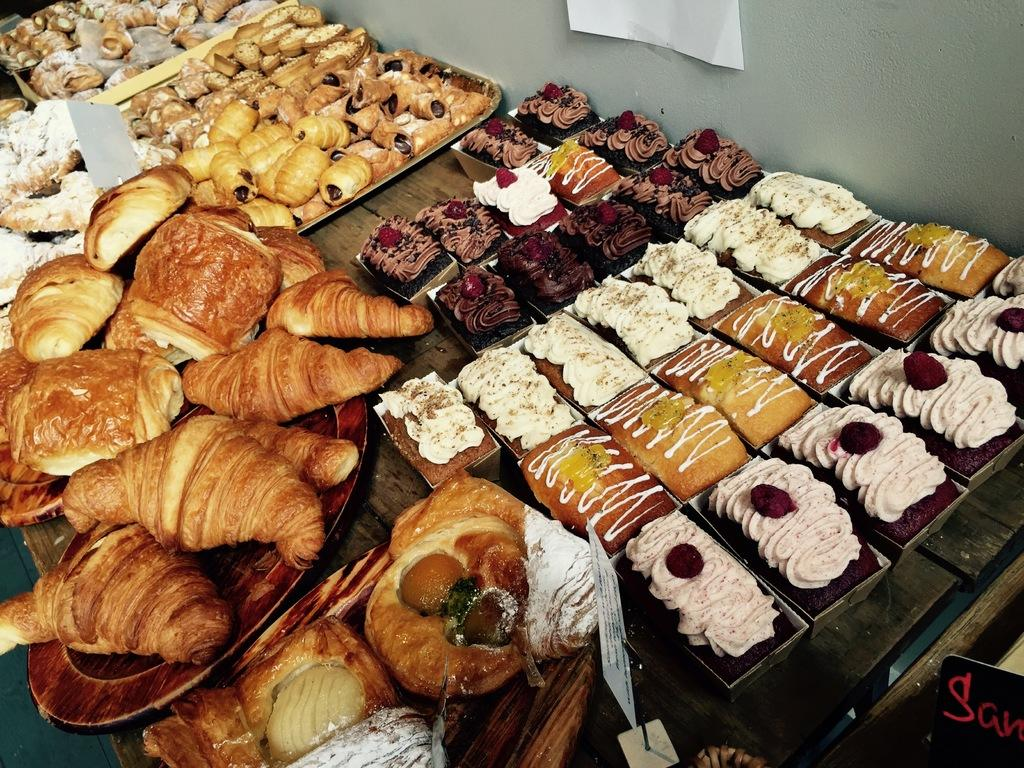What type of food items can be seen in the image? There are croissants and cakes in the image. How are the food items arranged in the image? The food items are on plates and trays in the image. Can you describe any additional features of the plates and trays? The plates and trays have name boards on them. What is the primary piece of furniture in the image? There is a table in the image. What can be seen in the background of the image? There is a wall in the background of the image. What is the opinion of the snails on the metal plates in the image? There are no snails or metal plates present in the image. 